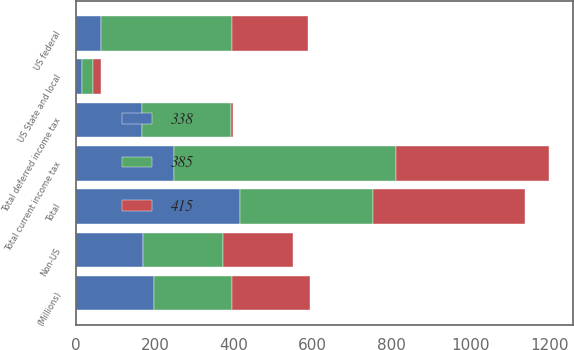Convert chart. <chart><loc_0><loc_0><loc_500><loc_500><stacked_bar_chart><ecel><fcel>(Millions)<fcel>US federal<fcel>Non-US<fcel>US State and local<fcel>Total current income tax<fcel>Total deferred income tax<fcel>Total<nl><fcel>385<fcel>198<fcel>332<fcel>203<fcel>28<fcel>563<fcel>225<fcel>338<nl><fcel>415<fcel>198<fcel>193<fcel>176<fcel>20<fcel>389<fcel>4<fcel>385<nl><fcel>338<fcel>198<fcel>62<fcel>170<fcel>15<fcel>247<fcel>168<fcel>415<nl></chart> 